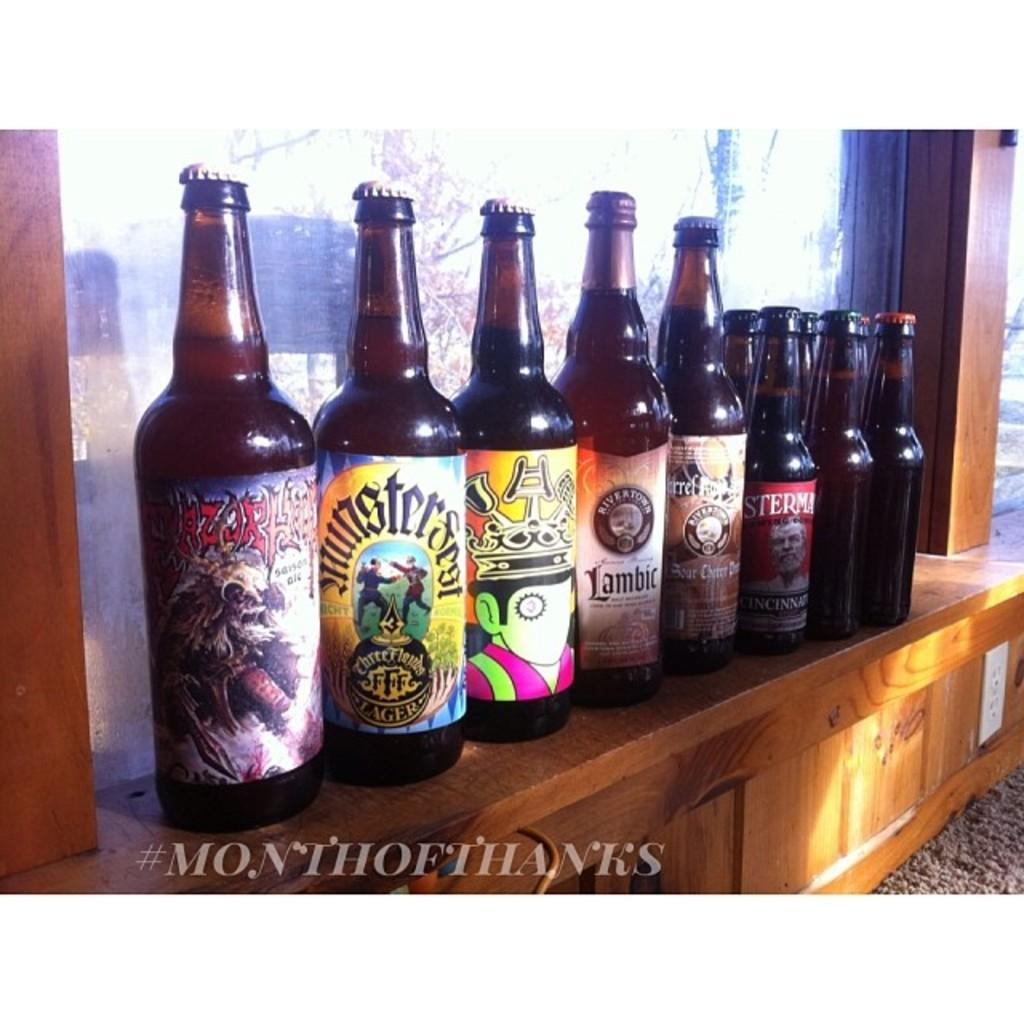<image>
Render a clear and concise summary of the photo. A bottle with a Lambic label has other bottles lined up on both sides of it. 